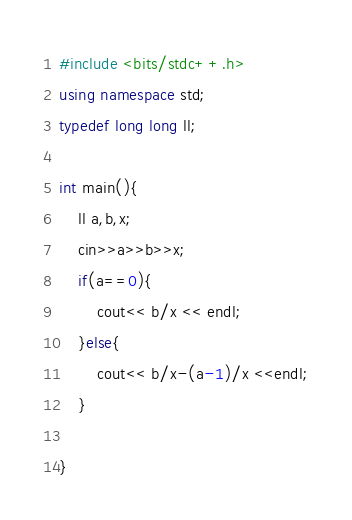Convert code to text. <code><loc_0><loc_0><loc_500><loc_500><_C++_>#include <bits/stdc++.h>
using namespace std;
typedef long long ll;

int main(){
    ll a,b,x;
    cin>>a>>b>>x;
    if(a==0){
        cout<< b/x << endl;
    }else{
        cout<< b/x-(a-1)/x <<endl;
    }
    
}
</code> 